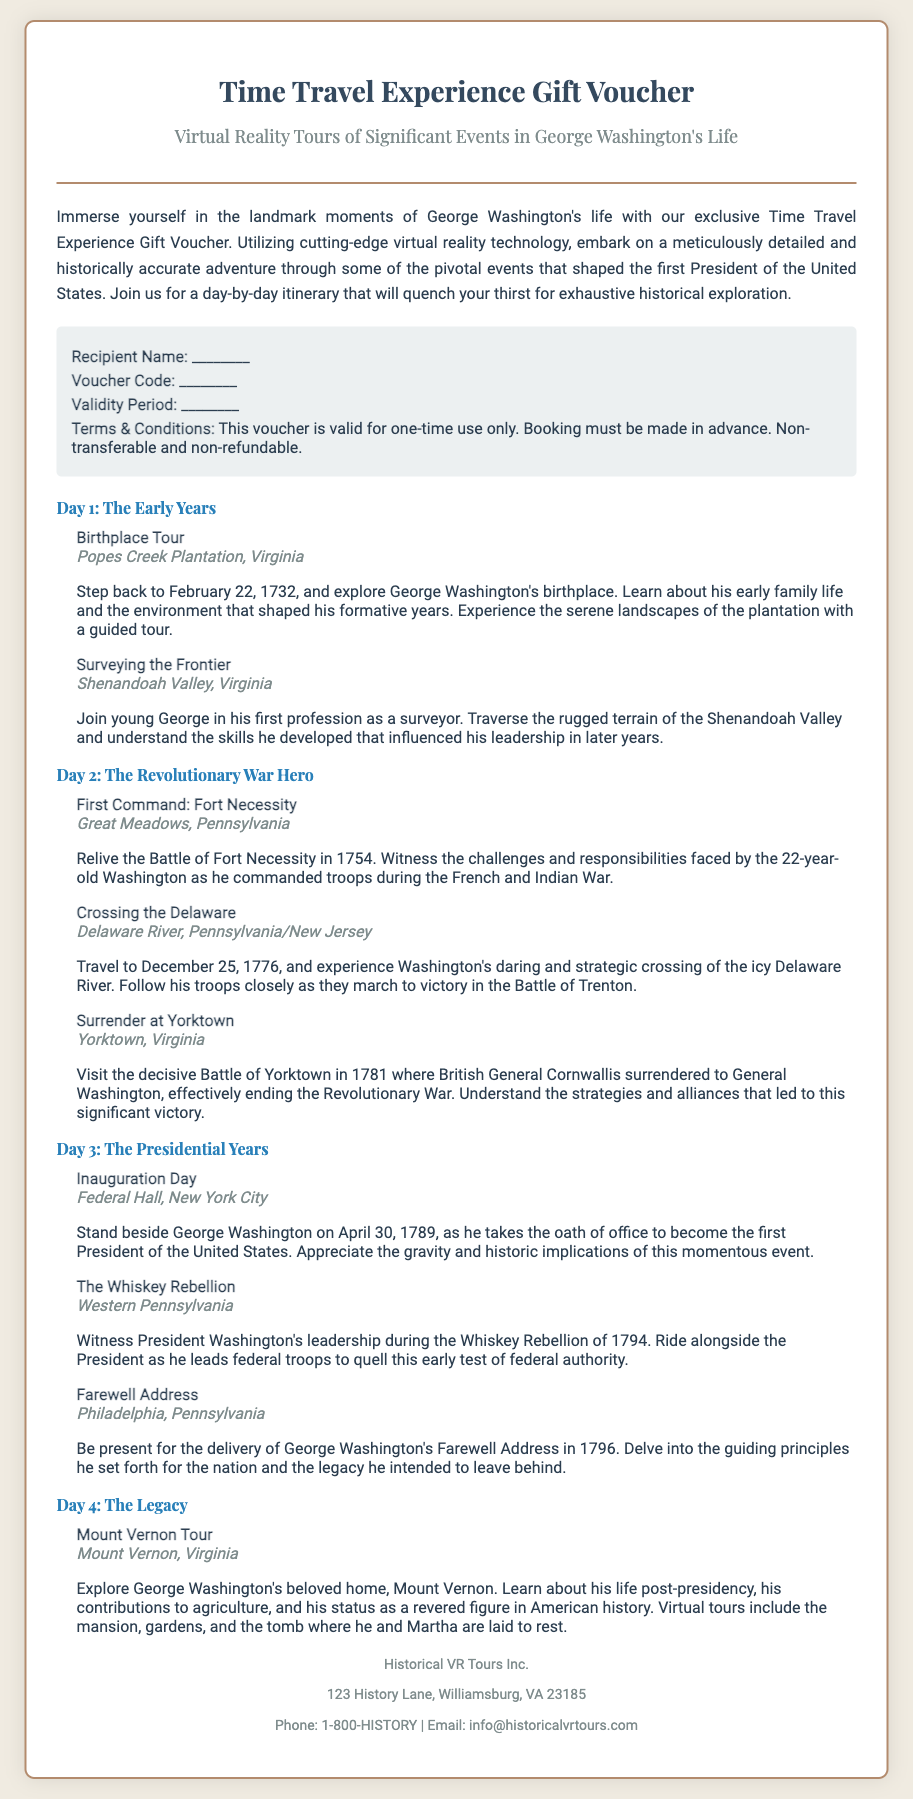What is the title of the voucher? The title of the voucher is explicitly stated at the top of the document.
Answer: Time Travel Experience Gift Voucher Who is the recipient of the voucher? The document includes a placeholder for the recipient's name.
Answer: ________ What is the validity period of the voucher? The document mentions a space to fill in the validity period, indicating the timeframe for use.
Answer: ________ Which day features the inauguration event? The event is detailed under Day 3 along with other presidential events.
Answer: Day 3 What location is associated with the Birthplace Tour? The document specifies the location of the Birthplace Tour.
Answer: Popes Creek Plantation, Virginia How many events are listed for Day 2? To find this, one must count the events provided under Day 2.
Answer: 3 Who delivered the Farewell Address? The document specifies that it was George Washington delivering the address.
Answer: George Washington What year does the Birthplace Tour reference? The document gives the exact year associated with this event.
Answer: 1732 What is the contact email provided in the document? The email for contacting the organization is stated at the end.
Answer: info@historicalvrtours.com 